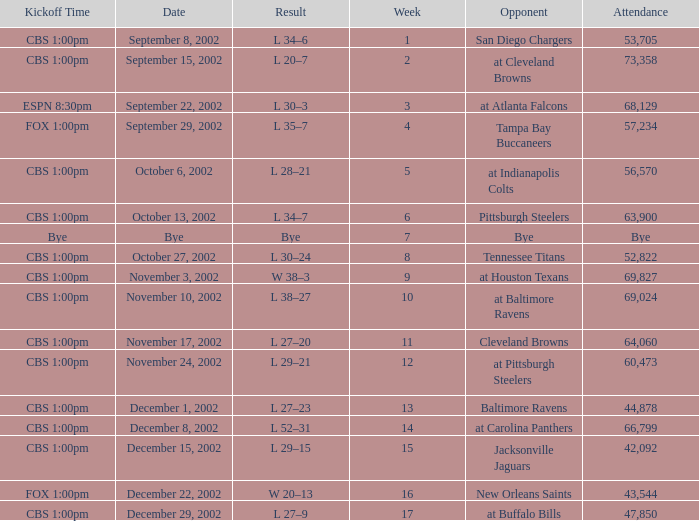What is the kickoff time on November 10, 2002? CBS 1:00pm. 